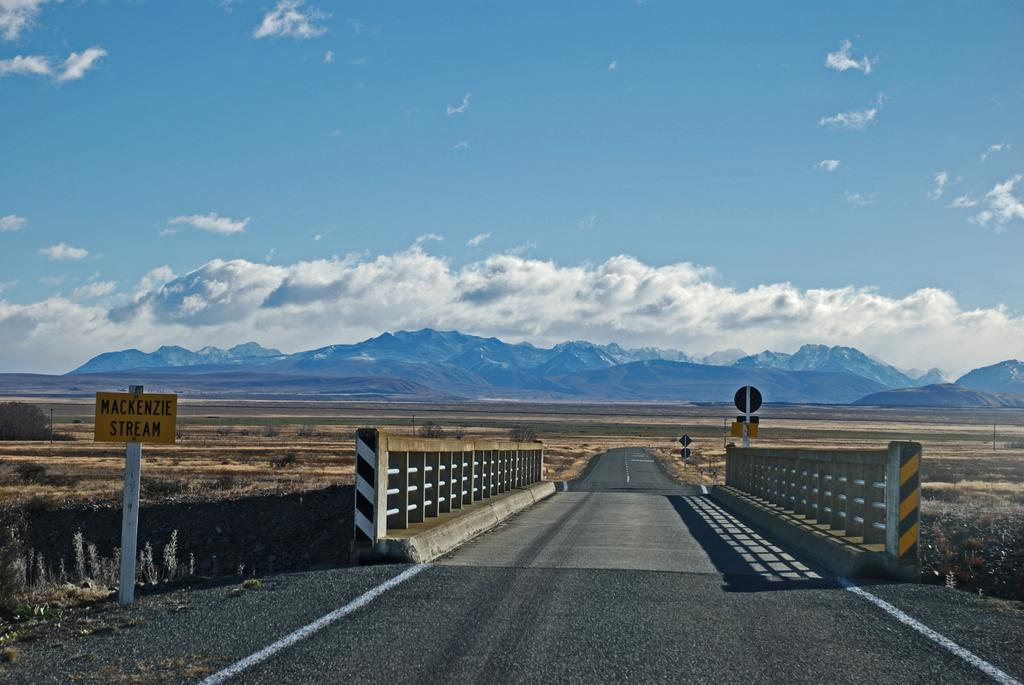What type of pathway is present in the image? There is a road in the image. What structure can be seen crossing over the road? There is a bridge in the image. What is placed alongside the road? There is a hoarding on the road. What natural feature can be seen in the distance? Mountains are visible in the background. How would you describe the weather based on the image? The sky is cloudy in the image. How many visitors are present in the bedroom in the image? There is no bedroom or visitors present in the image; it features a road, bridge, hoarding, mountains, and a cloudy sky. 